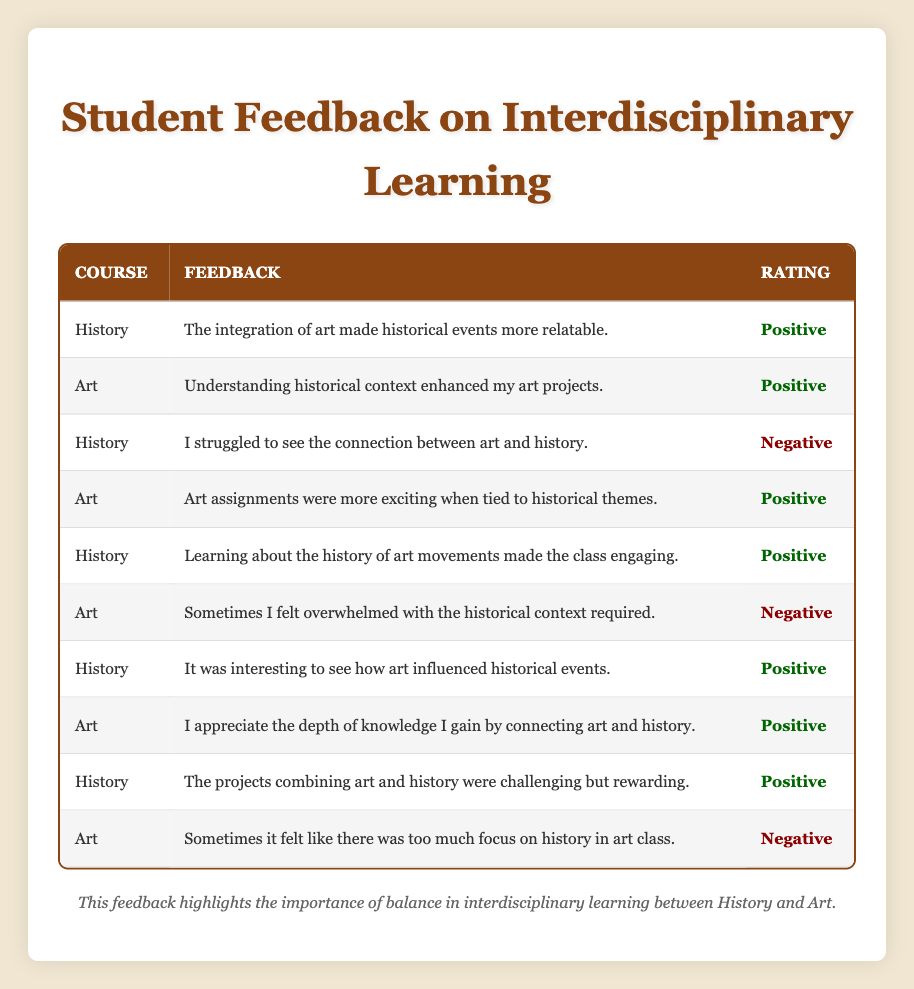What percentage of student feedback is positive for the History course? There are a total of 5 feedback entries for the History course. Of these, 4 entries are rated as positive. To find the percentage, I calculate (4/5) * 100, which equals 80%.
Answer: 80% What feedback did Student 5 provide in History? Student 5 provided the feedback: "Learning about the history of art movements made the class engaging." I can identify this directly from the table as it lists Student 5’s feedback under the History course.
Answer: Learning about the history of art movements made the class engaging Are there any negative feedback entries from students taking the Art course? Yes, there are two entries in the Art course that are rated as negative: one from Student 6 and one from Student 10. Checking the table shows that both have negative ratings.
Answer: Yes Which course has more positive feedback? For the History course, there are 4 positive feedbacks and for the Art course, there are 5 positive feedbacks. Adding both totals, History has 4 positives and Art has 5 positives, therefore Art has more positive feedback overall.
Answer: Art What is the overall sentiment of the student feedback regarding interdisciplinary learning in both courses? In total, there are 10 feedback entries. Out of these, 7 are positive and 3 are negative, leading to a positive sentiment overall. I derive this by counting the positive and negative ratings in the table. The ratio shows a clear inclination towards positive feedback.
Answer: Positive 